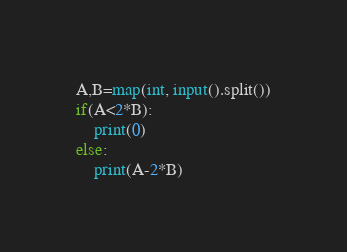<code> <loc_0><loc_0><loc_500><loc_500><_Python_>A,B=map(int, input().split())
if(A<2*B):
    print(0)
else:
    print(A-2*B)
</code> 